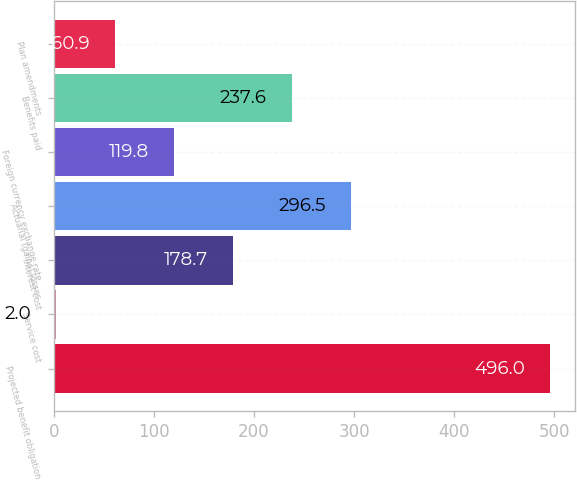Convert chart to OTSL. <chart><loc_0><loc_0><loc_500><loc_500><bar_chart><fcel>Projected benefit obligation<fcel>Service cost<fcel>Interest cost<fcel>Actuarial (gains) losses<fcel>Foreign currency exchange rate<fcel>Benefits paid<fcel>Plan amendments<nl><fcel>496<fcel>2<fcel>178.7<fcel>296.5<fcel>119.8<fcel>237.6<fcel>60.9<nl></chart> 